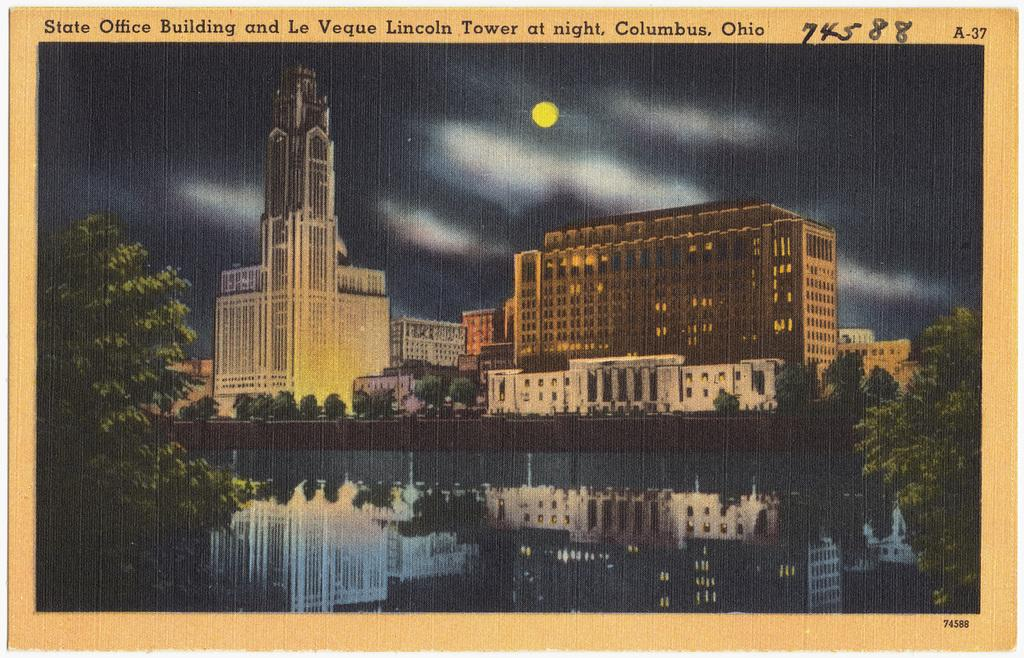What is featured in the image? There is a poster in the image. What can be seen in the foreground of the image? Water is visible in the foreground of the image. What is visible in the background of the image? There are buildings, trees, and the sky visible in the background of the image. Where is the text located in the image? The text is present in the bottom right and at the top of the image. How many clovers are growing in the image? There are no clovers present in the image. What type of clouds can be seen in the image? There are no clouds visible in the image; only the sky is visible in the background. 